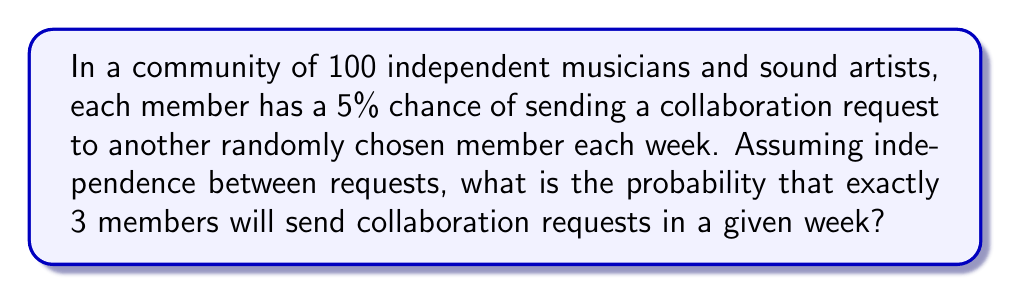Solve this math problem. To solve this problem, we can use the Binomial distribution, as we have a fixed number of independent trials (100 members) with a constant probability of success (5% chance of sending a request).

The probability mass function for the Binomial distribution is:

$$P(X = k) = \binom{n}{k} p^k (1-p)^{n-k}$$

Where:
$n$ = number of trials (100 members)
$k$ = number of successes (3 requests)
$p$ = probability of success (0.05 or 5%)

Let's calculate step by step:

1) First, we calculate the binomial coefficient:
   $$\binom{100}{3} = \frac{100!}{3!(100-3)!} = \frac{100 \cdot 99 \cdot 98}{3 \cdot 2 \cdot 1} = 161,700$$

2) Now, we can plug all values into the formula:
   $$P(X = 3) = 161,700 \cdot (0.05)^3 \cdot (1-0.05)^{100-3}$$

3) Simplify:
   $$P(X = 3) = 161,700 \cdot (0.05)^3 \cdot (0.95)^{97}$$

4) Calculate:
   $$P(X = 3) \approx 161,700 \cdot 0.000125 \cdot 0.0083 \approx 0.1678$$

Therefore, the probability that exactly 3 members will send collaboration requests in a given week is approximately 0.1678 or 16.78%.
Answer: $P(X = 3) \approx 0.1678$ or $16.78\%$ 